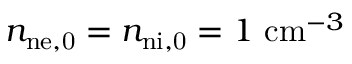Convert formula to latex. <formula><loc_0><loc_0><loc_500><loc_500>n _ { n { e , } 0 } = n _ { n { i , } 0 } = 1 c m ^ { - 3 }</formula> 